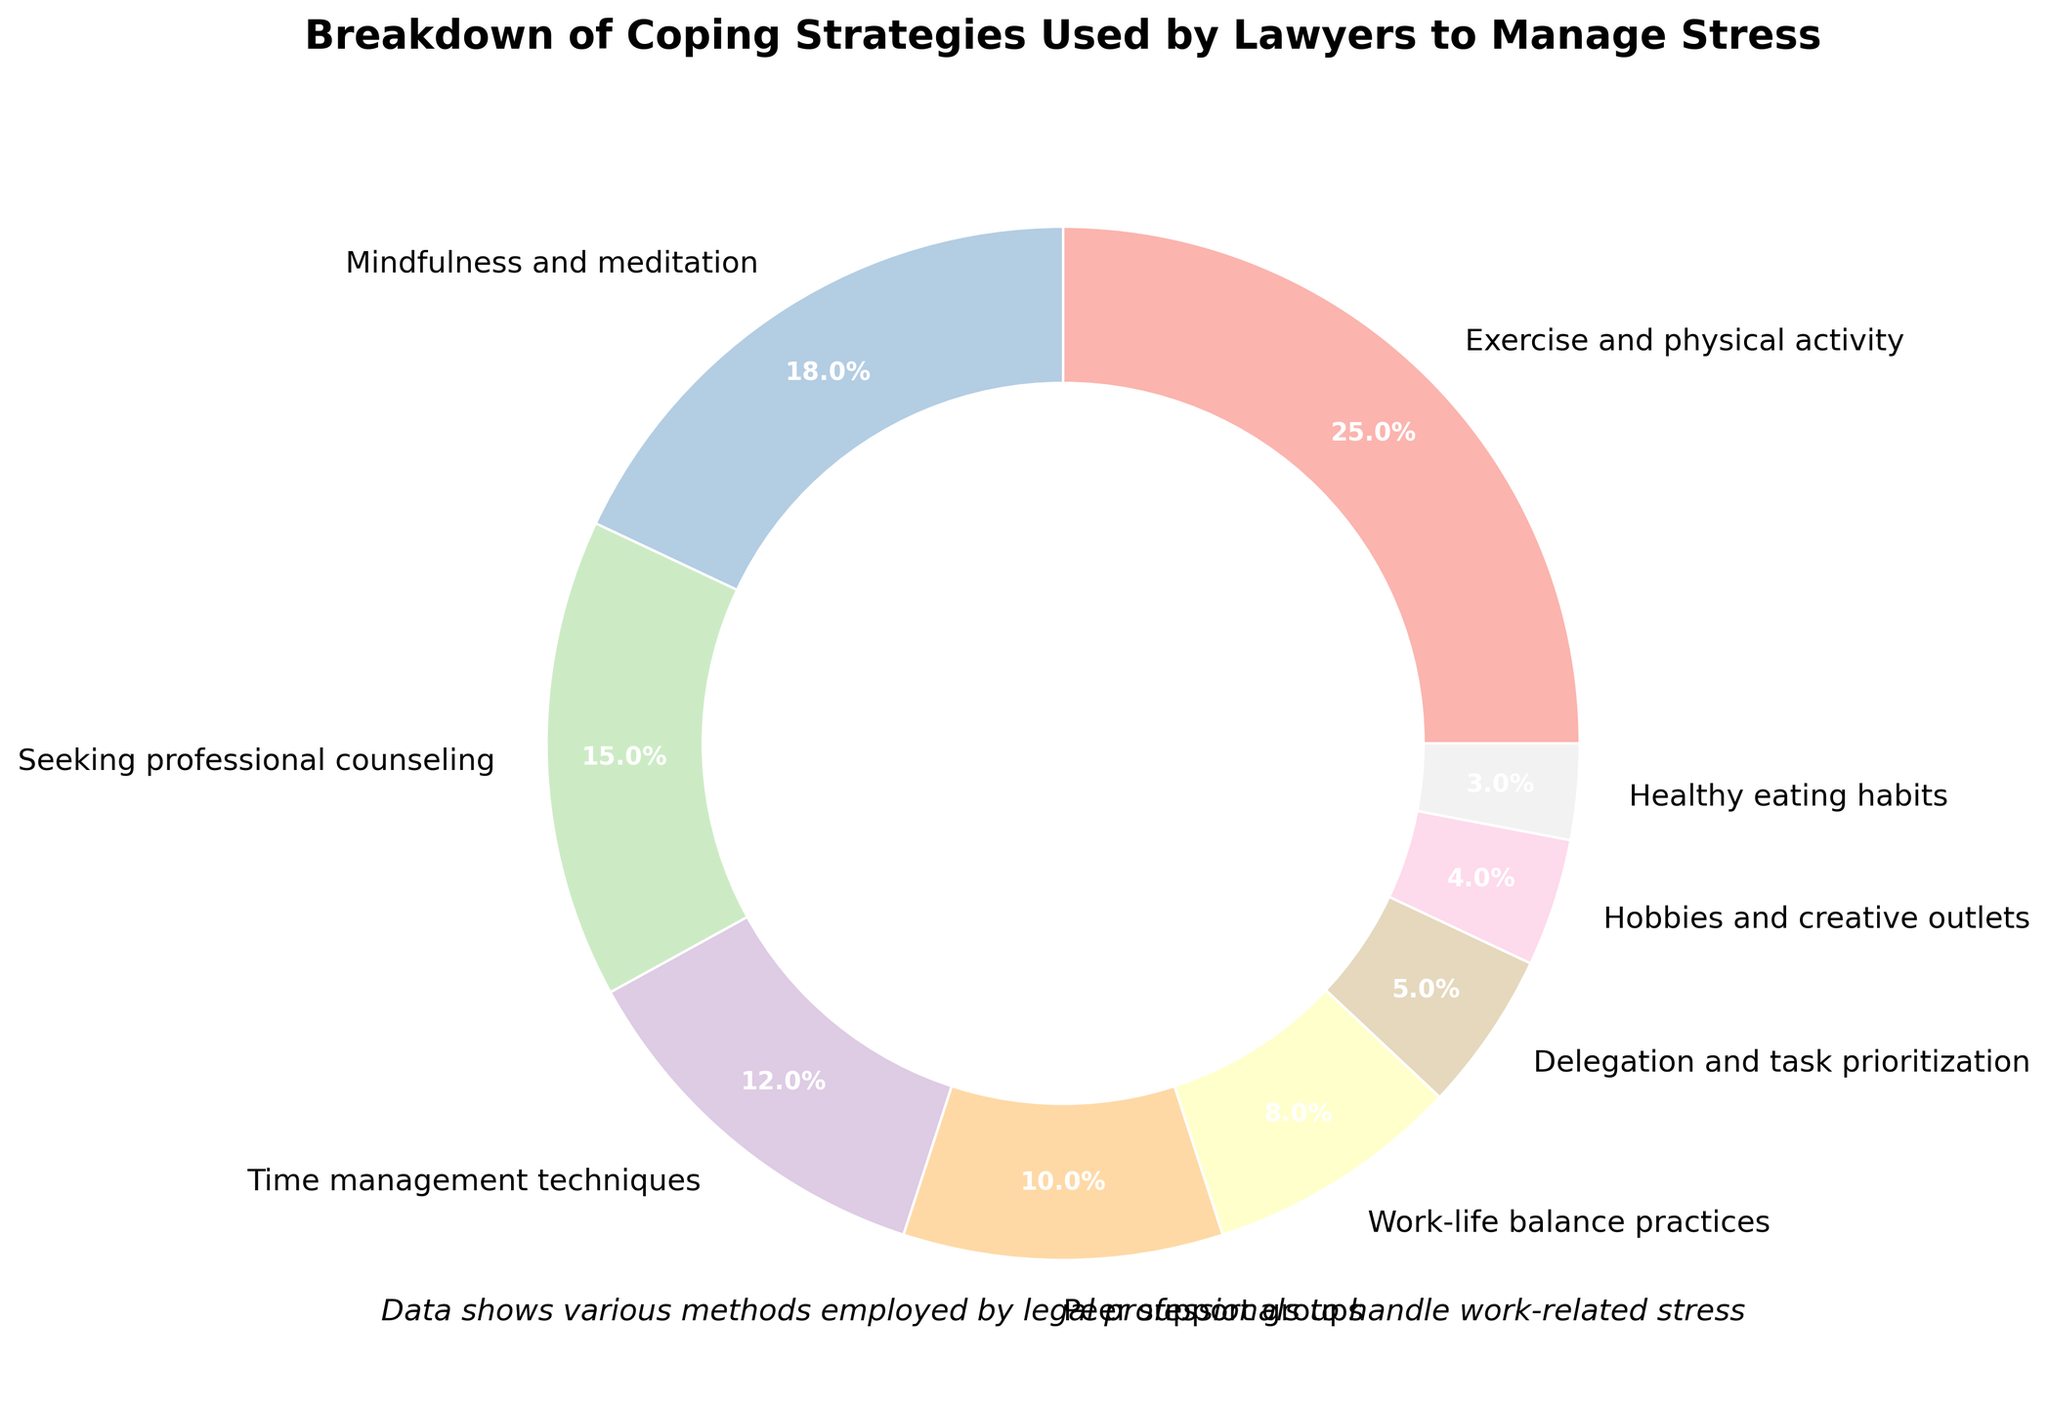what is the most commonly used coping strategy by lawyers? Look at the pie chart and find the segment with the largest percentage.
Answer: Exercise and physical activity Which coping strategy is used more, mindfulness and meditation or seeking professional counseling? Locate the segments representing both strategies. Compare their percentages.
Answer: Mindfulness and meditation What percentage of lawyers use exercise and physical activity combined with seeking professional counseling? Find the segments for both strategies and sum their percentages: 25% (Exercise) + 15% (Counseling).
Answer: 40% Which three coping strategies have the lowest percentage of use among lawyers? Identify the segments with the smallest percentages and list them.
Answer: Healthy eating habits, hobbies and creative outlets, delegation and task prioritization How many coping strategies have a usage percentage greater than 15%? Count the number of segments with a percentage over 15%.
Answer: 3 Is the use of peer support groups more or less than the use of time management techniques? Compare the percentages of both strategies.
Answer: Less What is the difference in percentage between work-life balance practices and delegation and task prioritization? Subtract the percentage of delegation and task prioritization from work-life balance practices: 8% - 5%.
Answer: 3% What's the combined percentage for all strategies involving personal well-being (exercise, mindfulness, healthy eating)? Sum the percentages of exercise, mindfulness, and healthy eating: 25% + 18% + 3%.
Answer: 46% Which strategy has approximately twice the percentage of healthy eating habits? Identify the strategy with roughly double the percentage of healthy eating (3% * 2 = 6%).
Answer: Delegation and task prioritization Which color represents the strategy "Hobbies and creative outlets"? Look at the pie chart and identify the color associated with the label "Hobbies and creative outlets".
Answer: It depends on the color in the chart, for example, if it's a specific color like yellow, you would list that color 